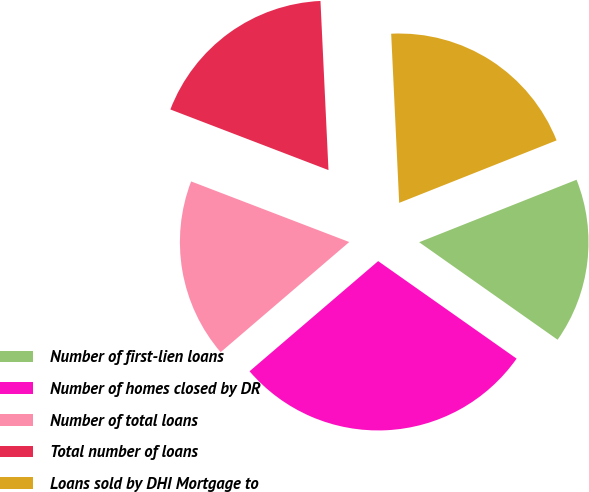Convert chart to OTSL. <chart><loc_0><loc_0><loc_500><loc_500><pie_chart><fcel>Number of first-lien loans<fcel>Number of homes closed by DR<fcel>Number of total loans<fcel>Total number of loans<fcel>Loans sold by DHI Mortgage to<nl><fcel>15.78%<fcel>28.96%<fcel>17.1%<fcel>18.42%<fcel>19.74%<nl></chart> 